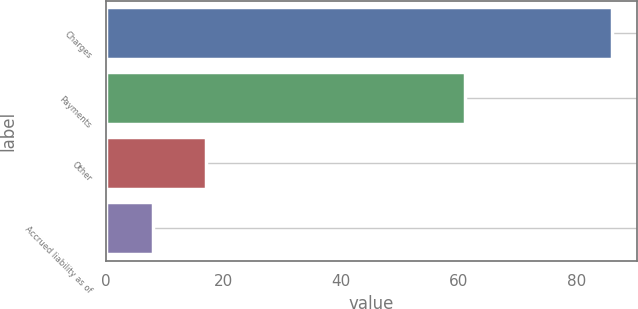<chart> <loc_0><loc_0><loc_500><loc_500><bar_chart><fcel>Charges<fcel>Payments<fcel>Other<fcel>Accrued liability as of<nl><fcel>86<fcel>61<fcel>17<fcel>8<nl></chart> 